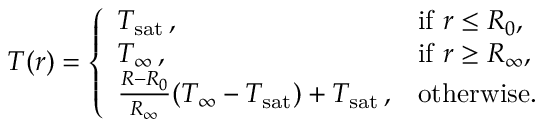<formula> <loc_0><loc_0><loc_500><loc_500>\begin{array} { r } { T ( r ) = \left \{ \begin{array} { l l } { T _ { s a t } \, , } & { i f r \leq R _ { 0 } , } \\ { T _ { \infty } \, , } & { i f r \geq R _ { \infty } , } \\ { \frac { R - R _ { 0 } } { R _ { \infty } } ( T _ { \infty } - T _ { s a t } ) + T _ { s a t } \, , } & { o t h e r w i s e . } \end{array} } \end{array}</formula> 